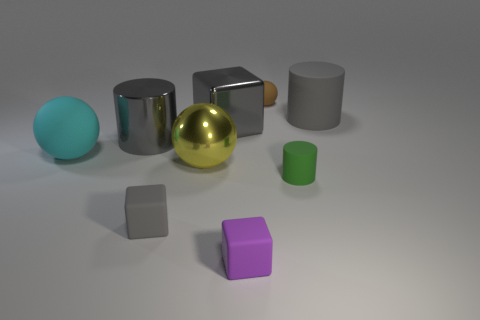Is the shape of the small purple thing the same as the small matte thing that is left of the purple rubber thing? Yes, the small purple object, which appears to be a cube, has the same geometric shape as the small, matte grey object situated to the left of the purple one. 